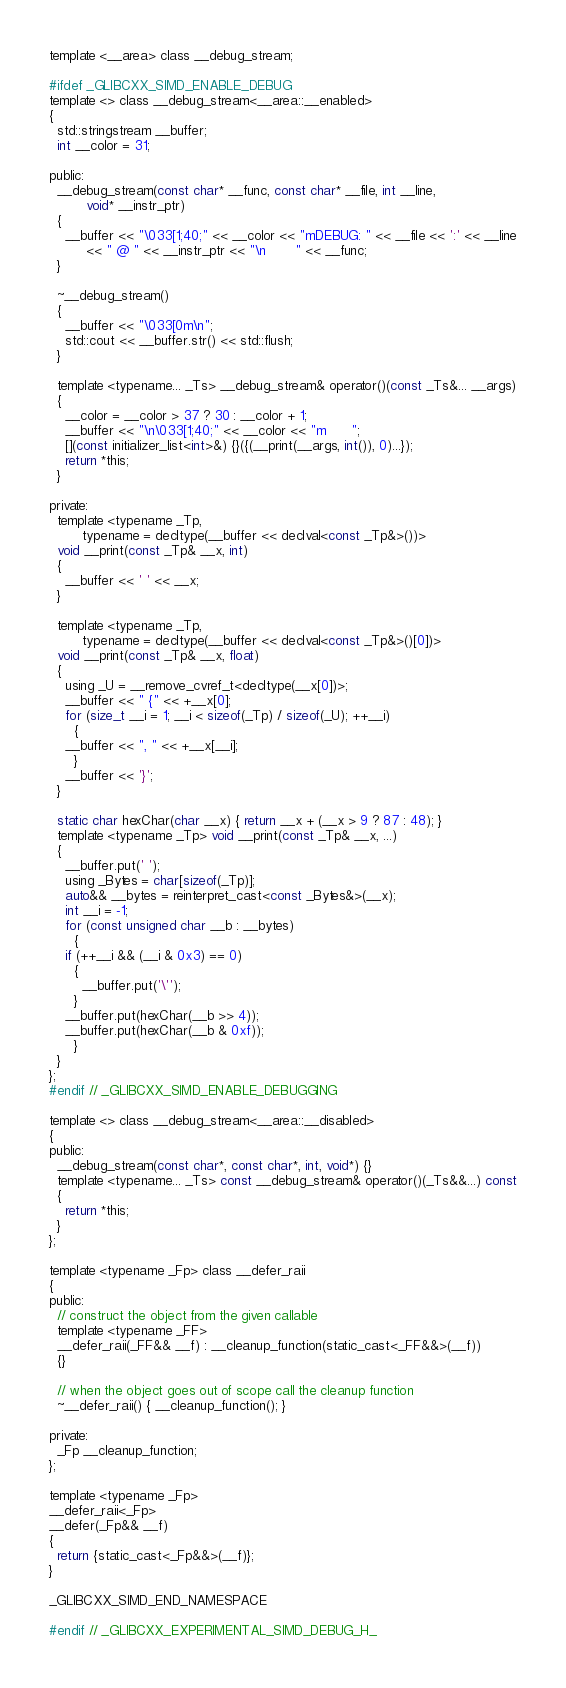<code> <loc_0><loc_0><loc_500><loc_500><_C_>
template <__area> class __debug_stream;

#ifdef _GLIBCXX_SIMD_ENABLE_DEBUG
template <> class __debug_stream<__area::__enabled>
{
  std::stringstream __buffer;
  int __color = 31;

public:
  __debug_stream(const char* __func, const char* __file, int __line,
		 void* __instr_ptr)
  {
    __buffer << "\033[1;40;" << __color << "mDEBUG: " << __file << ':' << __line
	     << " @ " << __instr_ptr << "\n       " << __func;
  }

  ~__debug_stream()
  {
    __buffer << "\033[0m\n";
    std::cout << __buffer.str() << std::flush;
  }

  template <typename... _Ts> __debug_stream& operator()(const _Ts&... __args)
  {
    __color = __color > 37 ? 30 : __color + 1;
    __buffer << "\n\033[1;40;" << __color << "m      ";
    [](const initializer_list<int>&) {}({(__print(__args, int()), 0)...});
    return *this;
  }

private:
  template <typename _Tp,
	    typename = decltype(__buffer << declval<const _Tp&>())>
  void __print(const _Tp& __x, int)
  {
    __buffer << ' ' << __x;
  }

  template <typename _Tp,
	    typename = decltype(__buffer << declval<const _Tp&>()[0])>
  void __print(const _Tp& __x, float)
  {
    using _U = __remove_cvref_t<decltype(__x[0])>;
    __buffer << " {" << +__x[0];
    for (size_t __i = 1; __i < sizeof(_Tp) / sizeof(_U); ++__i)
      {
	__buffer << ", " << +__x[__i];
      }
    __buffer << '}';
  }

  static char hexChar(char __x) { return __x + (__x > 9 ? 87 : 48); }
  template <typename _Tp> void __print(const _Tp& __x, ...)
  {
    __buffer.put(' ');
    using _Bytes = char[sizeof(_Tp)];
    auto&& __bytes = reinterpret_cast<const _Bytes&>(__x);
    int __i = -1;
    for (const unsigned char __b : __bytes)
      {
	if (++__i && (__i & 0x3) == 0)
	  {
	    __buffer.put('\'');
	  }
	__buffer.put(hexChar(__b >> 4));
	__buffer.put(hexChar(__b & 0xf));
      }
  }
};
#endif // _GLIBCXX_SIMD_ENABLE_DEBUGGING

template <> class __debug_stream<__area::__disabled>
{
public:
  __debug_stream(const char*, const char*, int, void*) {}
  template <typename... _Ts> const __debug_stream& operator()(_Ts&&...) const
  {
    return *this;
  }
};

template <typename _Fp> class __defer_raii
{
public:
  // construct the object from the given callable
  template <typename _FF>
  __defer_raii(_FF&& __f) : __cleanup_function(static_cast<_FF&&>(__f))
  {}

  // when the object goes out of scope call the cleanup function
  ~__defer_raii() { __cleanup_function(); }

private:
  _Fp __cleanup_function;
};

template <typename _Fp>
__defer_raii<_Fp>
__defer(_Fp&& __f)
{
  return {static_cast<_Fp&&>(__f)};
}

_GLIBCXX_SIMD_END_NAMESPACE

#endif // _GLIBCXX_EXPERIMENTAL_SIMD_DEBUG_H_
</code> 